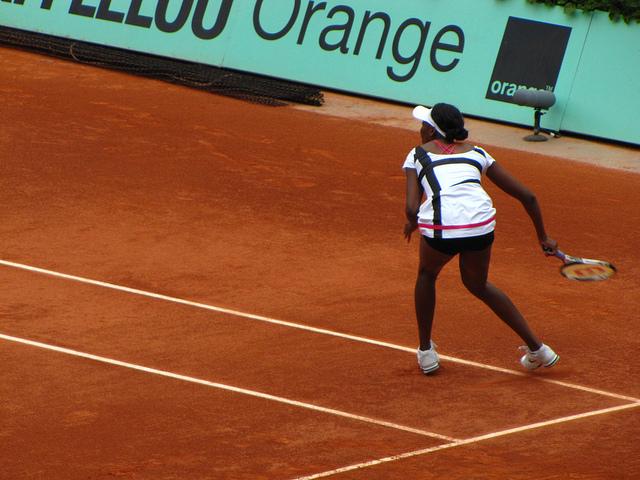Is this Serena Williams?
Answer briefly. No. What sport is this?
Concise answer only. Tennis. Will the player be able to return the ball?
Write a very short answer. Yes. What is the player holding in her right hand?
Give a very brief answer. Tennis racket. What type of surface is the player playing on?
Be succinct. Dirt. What language is on the wall?
Concise answer only. English. 